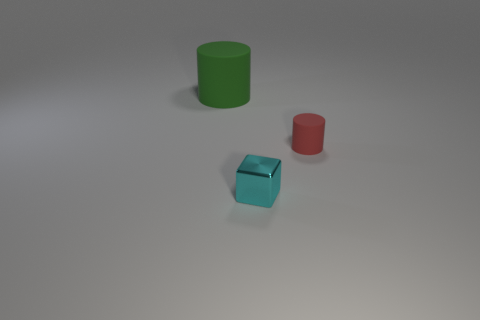Is the green object made of the same material as the cylinder that is to the right of the large green object?
Keep it short and to the point. Yes. What is the material of the cylinder that is behind the red rubber cylinder?
Give a very brief answer. Rubber. Are there the same number of tiny objects that are in front of the metallic thing and big matte things?
Your response must be concise. No. Are there any other things that are the same size as the green matte cylinder?
Ensure brevity in your answer.  No. What is the material of the object that is in front of the thing that is to the right of the metallic block?
Your answer should be compact. Metal. There is a object that is both behind the small cyan thing and left of the red object; what is its shape?
Ensure brevity in your answer.  Cylinder. The other thing that is the same shape as the red rubber thing is what size?
Provide a short and direct response. Large. Is the number of small cylinders that are behind the large cylinder less than the number of small cylinders?
Your answer should be compact. Yes. What size is the cylinder in front of the large cylinder?
Provide a short and direct response. Small. What is the color of the other matte thing that is the same shape as the red rubber object?
Ensure brevity in your answer.  Green. 